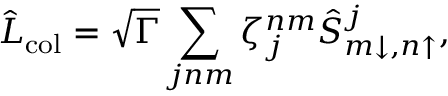Convert formula to latex. <formula><loc_0><loc_0><loc_500><loc_500>\hat { L } _ { c o l } = \sqrt { \Gamma } \sum _ { j n m } \zeta _ { j } ^ { n m } \hat { S } _ { m \downarrow , n \uparrow } ^ { j } ,</formula> 